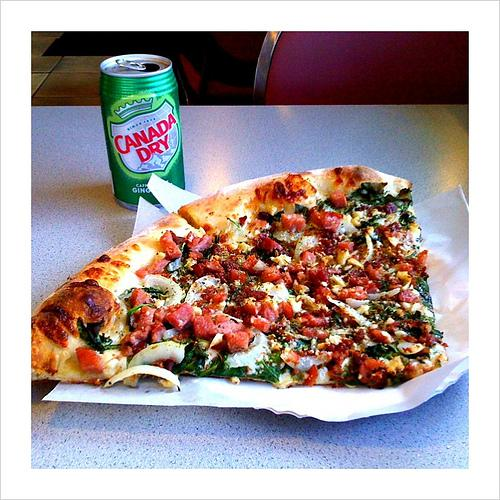Question: what is in the green can?
Choices:
A. There is canada dry ginger in the can.
B. Paint.
C. Peanuts.
D. Fruit.
Answer with the letter. Answer: A Question: who is in the picture?
Choices:
A. My grandparents.
B. My best friends.
C. My aunt and uncle.
D. Nobody is in the picture.
Answer with the letter. Answer: D Question: what color is the table?
Choices:
A. Black.
B. Brown.
C. The table is white.
D. Gray.
Answer with the letter. Answer: C Question: what is on the pizza?
Choices:
A. Pineapple and Ham.
B. There is vegetables and seasoning on the pizza.
C. A little plastic piece to prevent the cheese getting stuck to the cardboard box.
D. A fork and knife.
Answer with the letter. Answer: B 